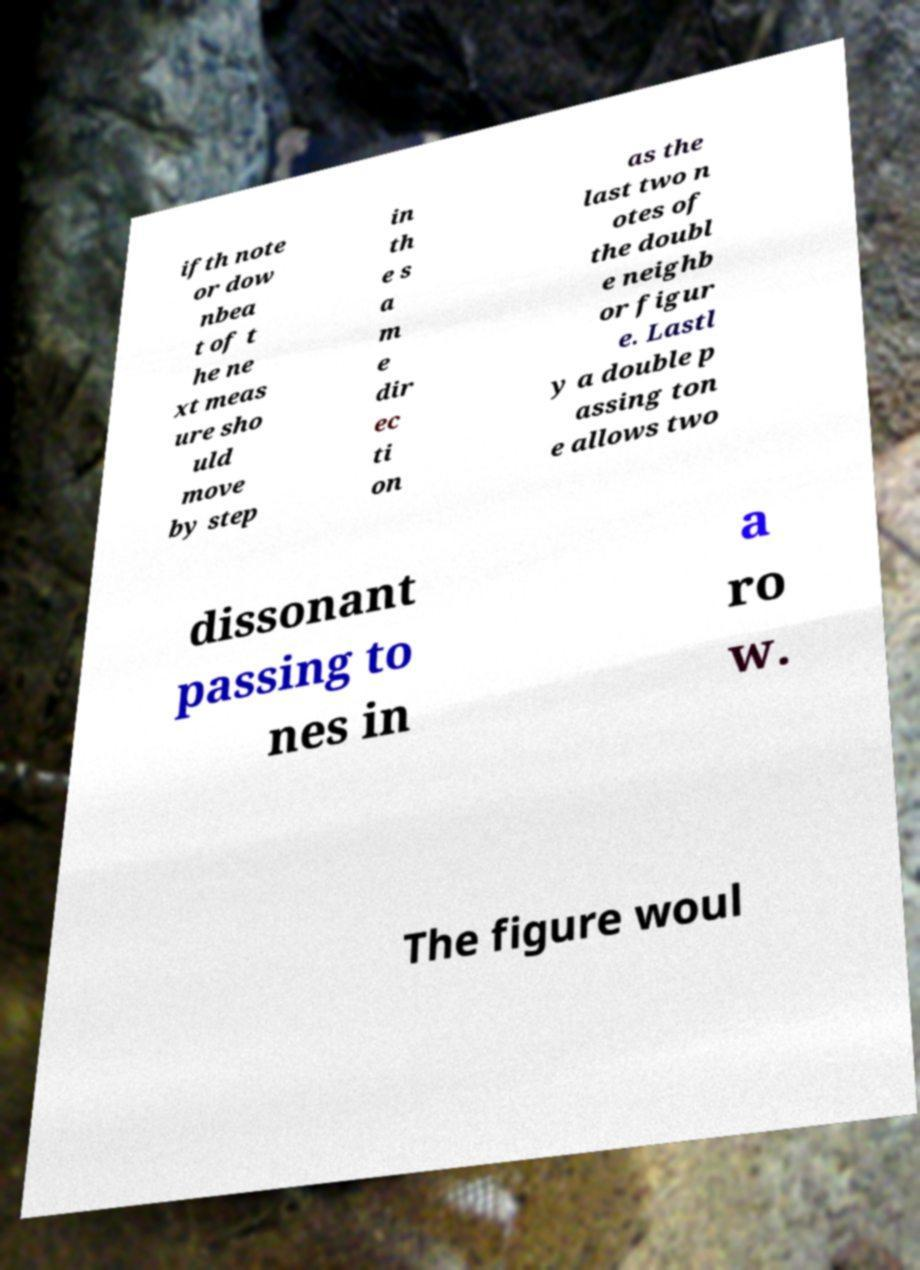Can you read and provide the text displayed in the image?This photo seems to have some interesting text. Can you extract and type it out for me? ifth note or dow nbea t of t he ne xt meas ure sho uld move by step in th e s a m e dir ec ti on as the last two n otes of the doubl e neighb or figur e. Lastl y a double p assing ton e allows two dissonant passing to nes in a ro w. The figure woul 